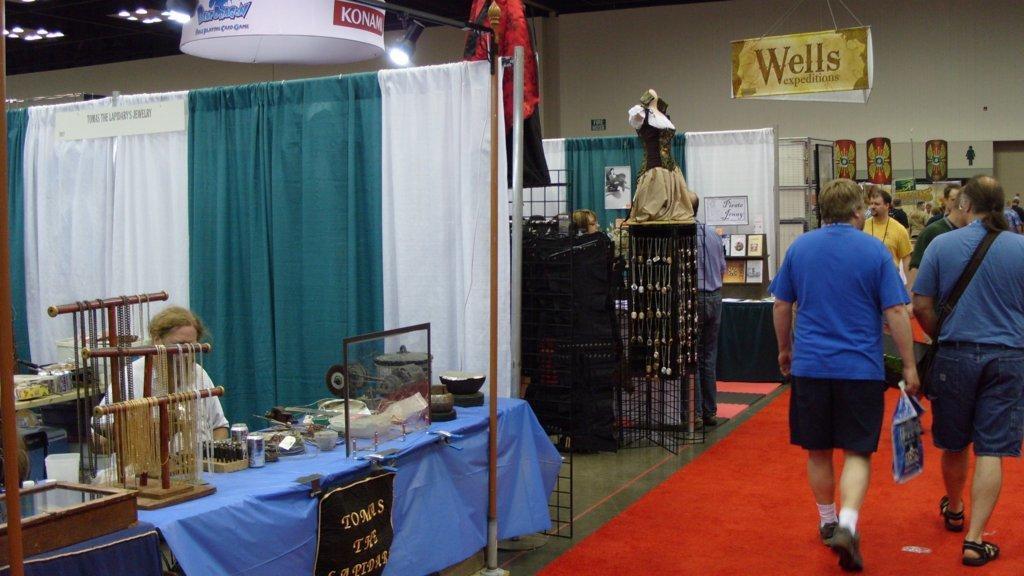How would you summarize this image in a sentence or two? In this image we can see few people walking on the right side. On the floor there is red carpet. On the left side there is a person sitting. There are tables. On the tables there are many items. Also there is something written on a board. There is a stand with a board. On the board something is written. On the ceiling there are lights. Also there are curtains. In the back there are many items. Also there is a mannequin with a dress on a stand. And there is a board hanged. On that something is written. 